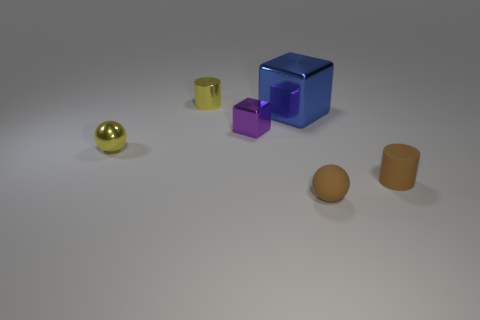Is there anything else that has the same size as the blue thing?
Offer a very short reply. No. What is the brown ball made of?
Offer a very short reply. Rubber. What number of small things are to the right of the tiny brown ball and left of the blue metal object?
Provide a succinct answer. 0. Do the blue shiny block and the purple metallic block have the same size?
Make the answer very short. No. Do the cylinder that is on the right side of the metal cylinder and the big blue shiny object have the same size?
Ensure brevity in your answer.  No. There is a small sphere that is in front of the tiny metal sphere; what is its color?
Give a very brief answer. Brown. How many yellow matte blocks are there?
Offer a terse response. 0. There is a blue object that is made of the same material as the tiny purple object; what shape is it?
Your response must be concise. Cube. There is a tiny matte object in front of the tiny brown cylinder; is its color the same as the tiny ball that is behind the small rubber sphere?
Offer a terse response. No. Are there the same number of small yellow metallic things behind the brown ball and large cyan cubes?
Offer a very short reply. No. 